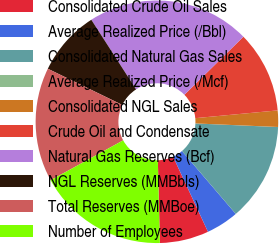<chart> <loc_0><loc_0><loc_500><loc_500><pie_chart><fcel>Consolidated Crude Oil Sales<fcel>Average Realized Price (/Bbl)<fcel>Consolidated Natural Gas Sales<fcel>Average Realized Price (/Mcf)<fcel>Consolidated NGL Sales<fcel>Crude Oil and Condensate<fcel>Natural Gas Reserves (Bcf)<fcel>NGL Reserves (MMBbls)<fcel>Total Reserves (MMBoe)<fcel>Number of Employees<nl><fcel>6.53%<fcel>4.35%<fcel>13.04%<fcel>0.01%<fcel>2.18%<fcel>10.87%<fcel>21.73%<fcel>8.7%<fcel>15.21%<fcel>17.38%<nl></chart> 